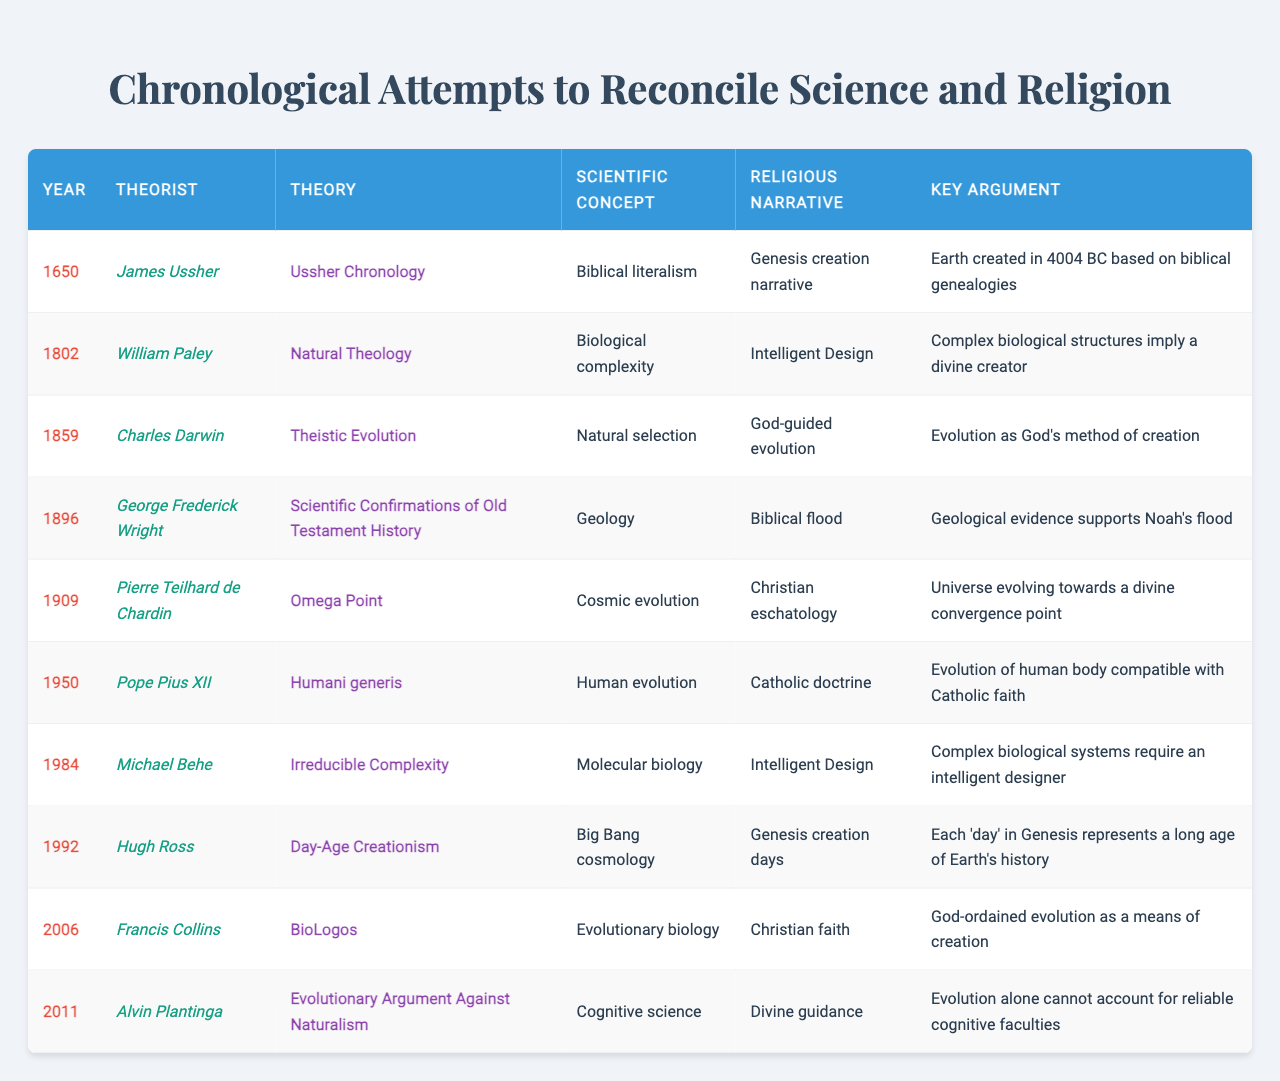What year did James Ussher present his chronology? According to the table, James Ussher presented his chronology in the year 1650.
Answer: 1650 What is the key argument of Pierre Teilhard de Chardin's Omega Point theory? The table indicates that the key argument for Pierre Teilhard de Chardin's Omega Point theory is that the universe is evolving towards a divine convergence point.
Answer: Universe evolving towards a divine convergence point Who theorized that evolution is compatible with Catholic doctrine, and in what year? The table shows that Pope Pius XII theorized that evolution is compatible with Catholic doctrine in the year 1950.
Answer: Pope Pius XII, 1950 How many theories related to the concept of Intelligent Design are listed? The table lists two theories related to Intelligent Design, attributed to William Paley (1802) and Michael Behe (1984).
Answer: 2 What is the scientific concept associated with Hugh Ross's Day-Age Creationism? According to the table, the scientific concept associated with Hugh Ross's Day-Age Creationism is Big Bang cosmology.
Answer: Big Bang cosmology What was the earliest and the latest year represented in the table? The earliest year is 1650 (James Ussher), and the latest is 2011 (Alvin Plantinga), showing a range of 361 years.
Answer: 1650, 2011 Did George Frederick Wright support the biblical flood narrative with scientific evidence? Yes, the table confirms that George Frederick Wright's theory provided geological evidence to support the biblical flood narrative.
Answer: Yes Based on the table, what evidence does Alvin Plantinga provide against naturalism? Alvin Plantinga argues that evolution alone cannot account for reliable cognitive faculties, according to the table.
Answer: Evolution cannot account for reliable cognitive faculties Which theorist’s work suggests that complex biological systems require an intelligent designer? The table indicates that Michael Behe’s theory of Irreducible Complexity suggests that complex biological systems need an intelligent designer.
Answer: Michael Behe What common theme is shared between Charles Darwin's and Francis Collins' theories? Both theories, Theistic Evolution by Darwin and BioLogos by Collins, suggest that evolution is a method of God's creation, as noted in the table.
Answer: God’s method of creation through evolution 